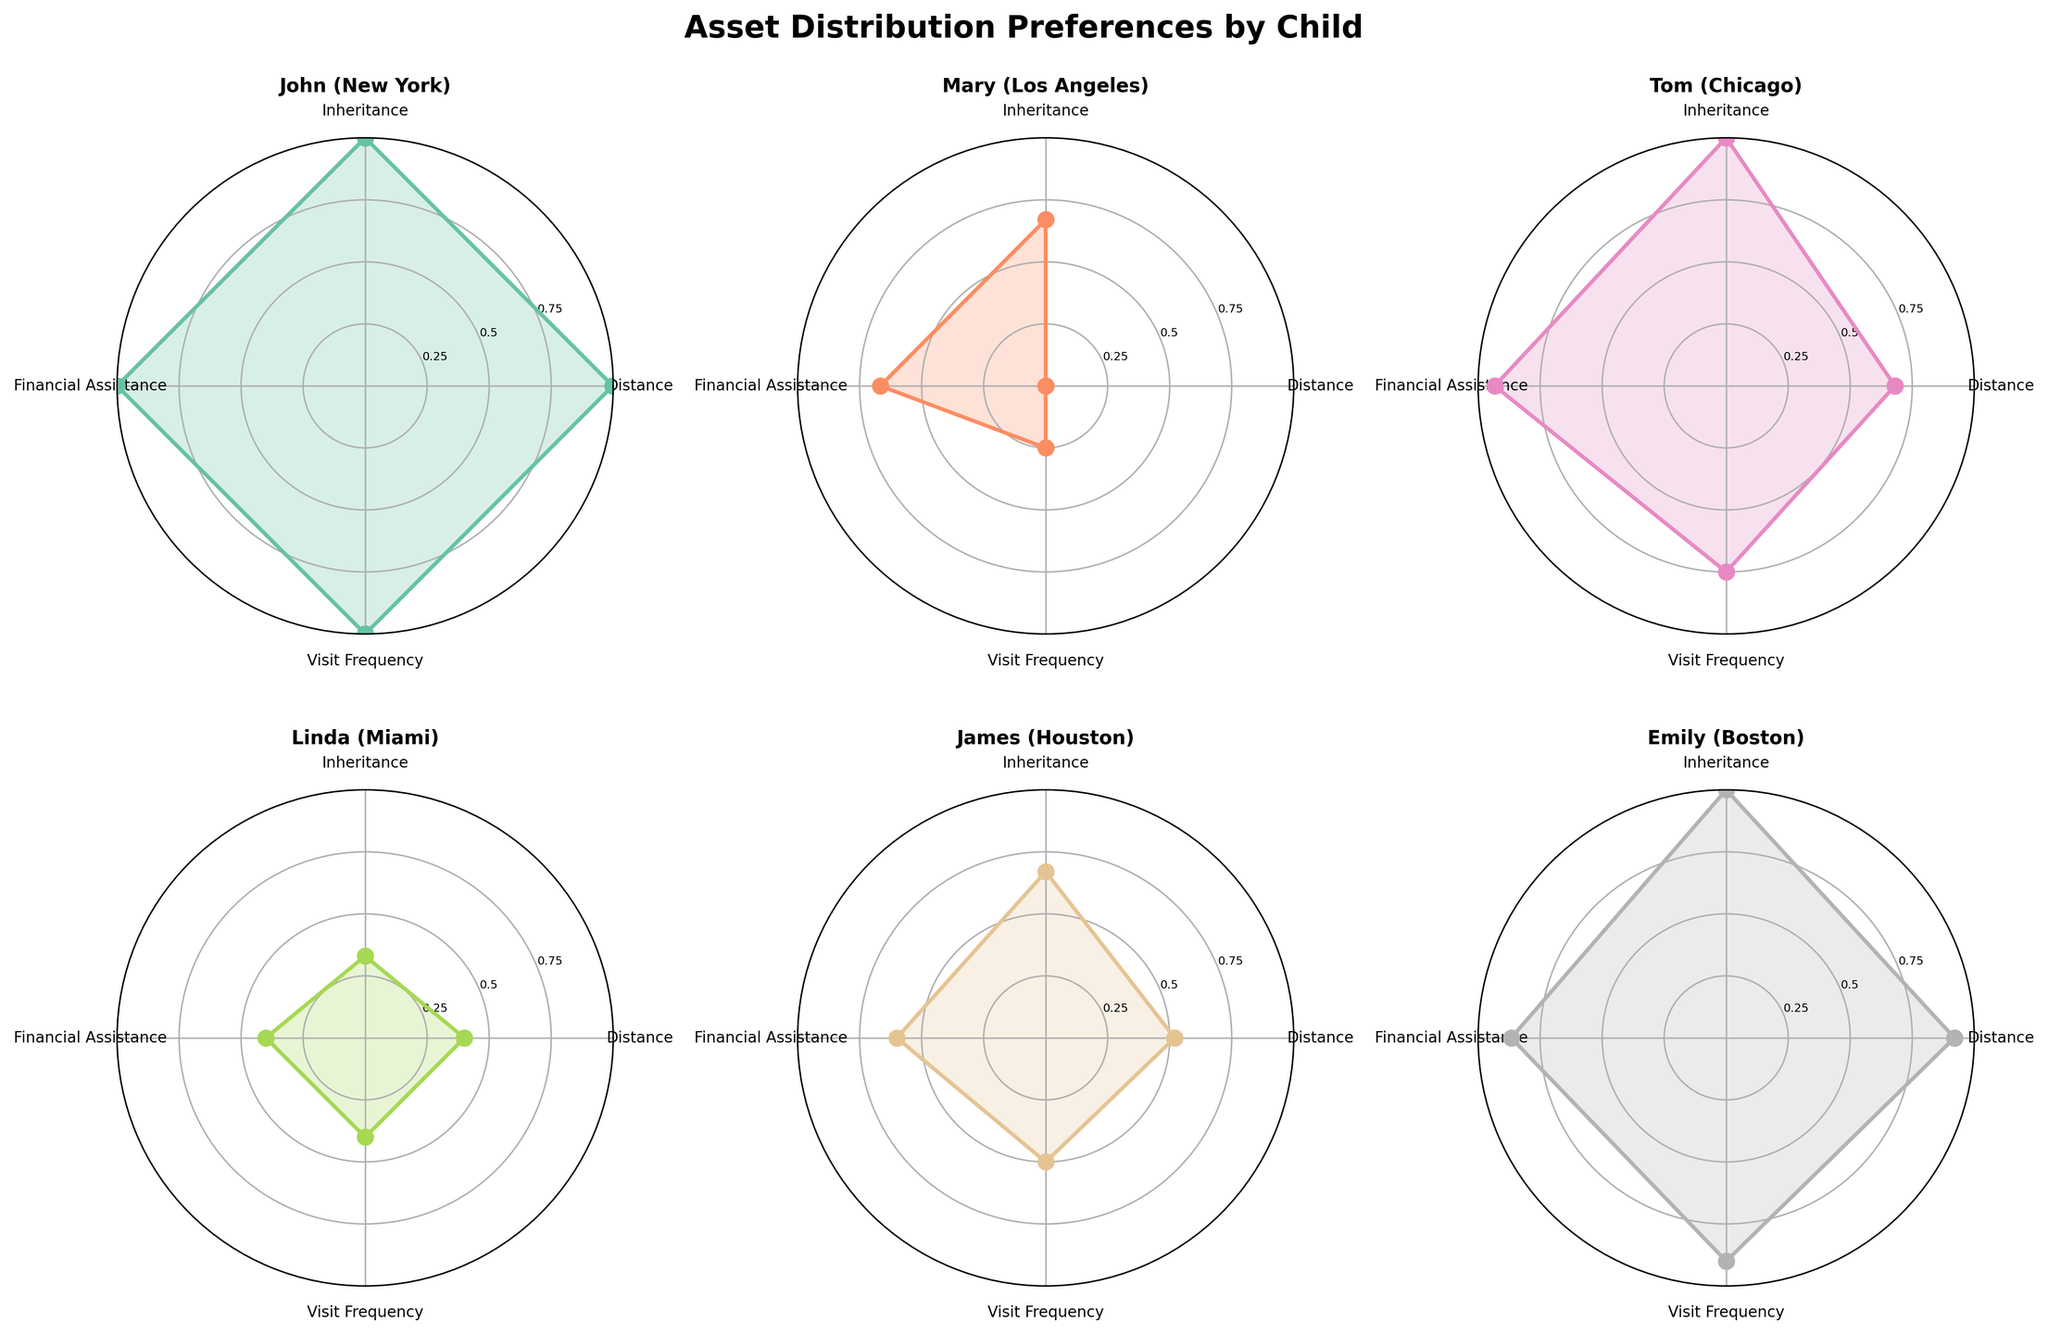What are the four categories displayed on the radar charts? The radar charts have labels on the axes indicating the categories, which are Distance, Inheritance, Financial Assistance, and Visit Frequency.
Answer: Distance, Inheritance, Financial Assistance, Visit Frequency Which child has the highest normalized score for Visit Frequency? By looking at the subplot for each child and comparing their normalized values along the Visit Frequency axis, we see that John in New York has the highest score nearly reaching the outer edge.
Answer: John How does financial assistance preference compare between Mary and Tom? On their respective radar charts, the normalized score for Financial Assistance for Mary is lower than that for Tom, indicating Tom receives more financial assistance annually.
Answer: Tom receives more financial assistance than Mary What are the normalized values for Linda's Financial Assistance and Inheritance Preference? On Linda's radar chart (Miami), the values can be read off the axes. Financial Assistance is around 0.33 (scaled value of $3000) and Inheritance Preference is at the lowest point (0.33 for Low).
Answer: 0.33 for both If John's Visit Frequency increases by 2 times per year, how will his normalized score change? Initially, John's Visit Frequency is 20 times per year. If it increases by 2, it would be 22 times per year. Given the maximum visit frequency among all children is 20 (from the radar chart), John's normalized score would remain at 1 since 20/20 = 1 and 22/22 = 1.
Answer: It remains unchanged at 1 Which two children have the closest normalized scores for Distance to Retiree's Residence? Reviewing the Distance axis, John and Emily have normalized scores closest to each other. John's score is slightly higher since he lives 5 miles away compared to Emily's 200 miles.
Answer: John and Emily Which child has the lowest normalized score for Financial Assistance? Checking the Financial Assistance axis on each radar chart, Linda in Miami has the lowest score at around 0.33 corresponding to $3000 per year.
Answer: Linda How does James' Visit Frequency compare to the average Visit Frequency of all children? First, calculate the average visit frequency: (20 + 5 + 15 + 8 + 10 + 18) / 6 = 12 visits per year. James visits 10 times per year, which is slightly below this average.
Answer: Slightly below the average Which child has a higher normalized Inheritance Preference: Emily or Mary? Comparing their radar charts, Emily in Boston has a higher normalized score for Inheritance Preference (1 for High) compared to Mary's Medium preference (approximately 0.67).
Answer: Emily 